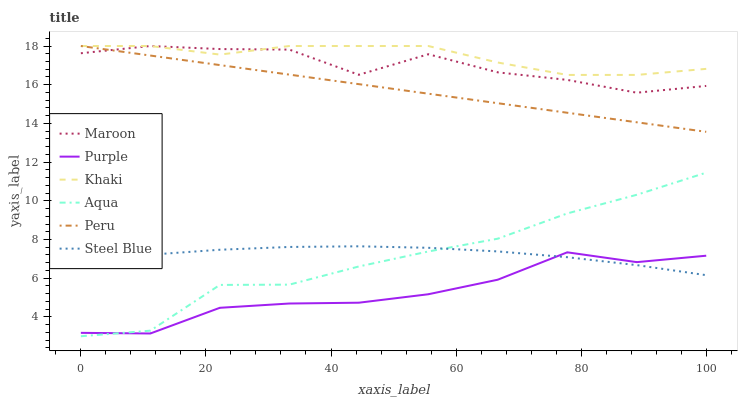Does Purple have the minimum area under the curve?
Answer yes or no. Yes. Does Khaki have the maximum area under the curve?
Answer yes or no. Yes. Does Aqua have the minimum area under the curve?
Answer yes or no. No. Does Aqua have the maximum area under the curve?
Answer yes or no. No. Is Peru the smoothest?
Answer yes or no. Yes. Is Maroon the roughest?
Answer yes or no. Yes. Is Purple the smoothest?
Answer yes or no. No. Is Purple the roughest?
Answer yes or no. No. Does Purple have the lowest value?
Answer yes or no. No. Does Peru have the highest value?
Answer yes or no. Yes. Does Aqua have the highest value?
Answer yes or no. No. Is Purple less than Maroon?
Answer yes or no. Yes. Is Peru greater than Purple?
Answer yes or no. Yes. Does Khaki intersect Peru?
Answer yes or no. Yes. Is Khaki less than Peru?
Answer yes or no. No. Is Khaki greater than Peru?
Answer yes or no. No. Does Purple intersect Maroon?
Answer yes or no. No. 